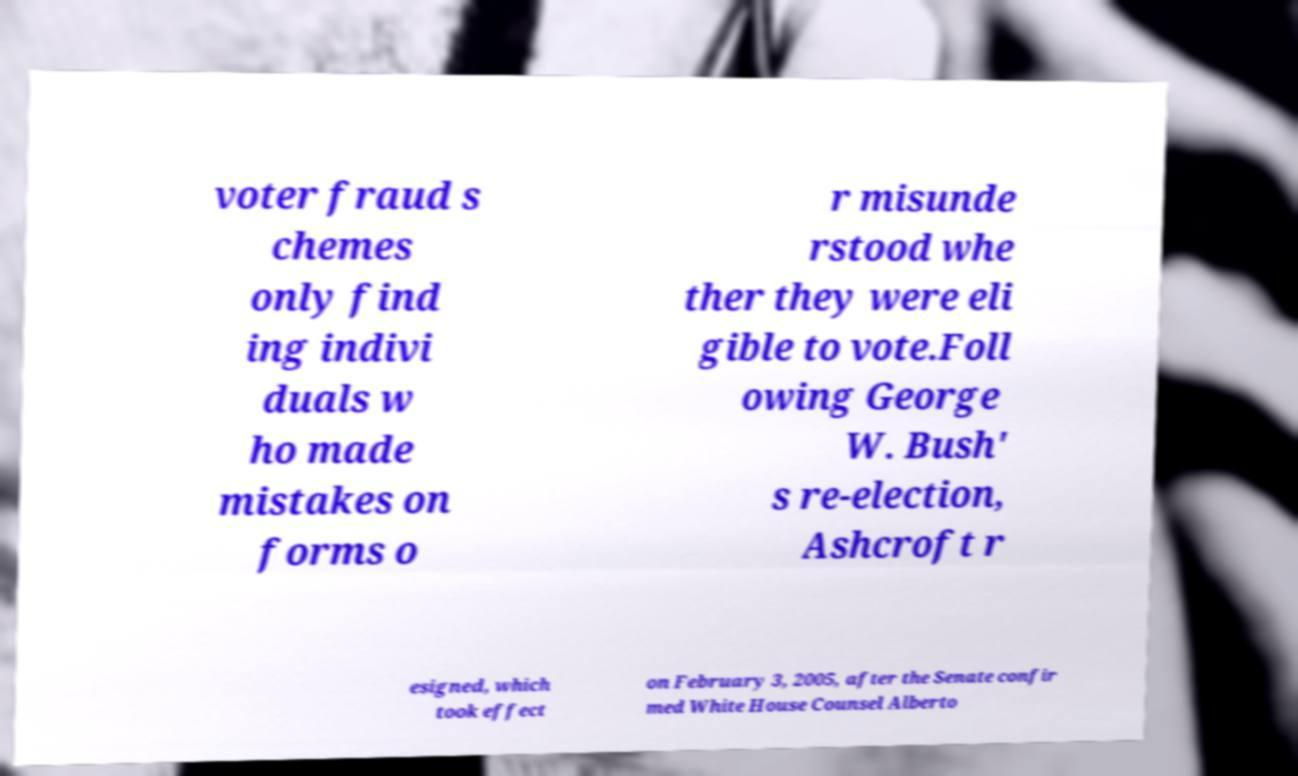Can you read and provide the text displayed in the image?This photo seems to have some interesting text. Can you extract and type it out for me? voter fraud s chemes only find ing indivi duals w ho made mistakes on forms o r misunde rstood whe ther they were eli gible to vote.Foll owing George W. Bush' s re-election, Ashcroft r esigned, which took effect on February 3, 2005, after the Senate confir med White House Counsel Alberto 